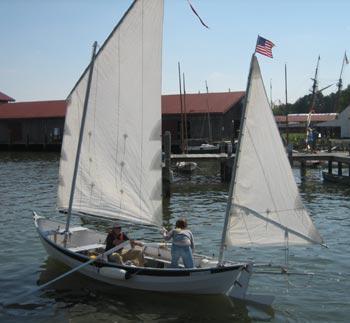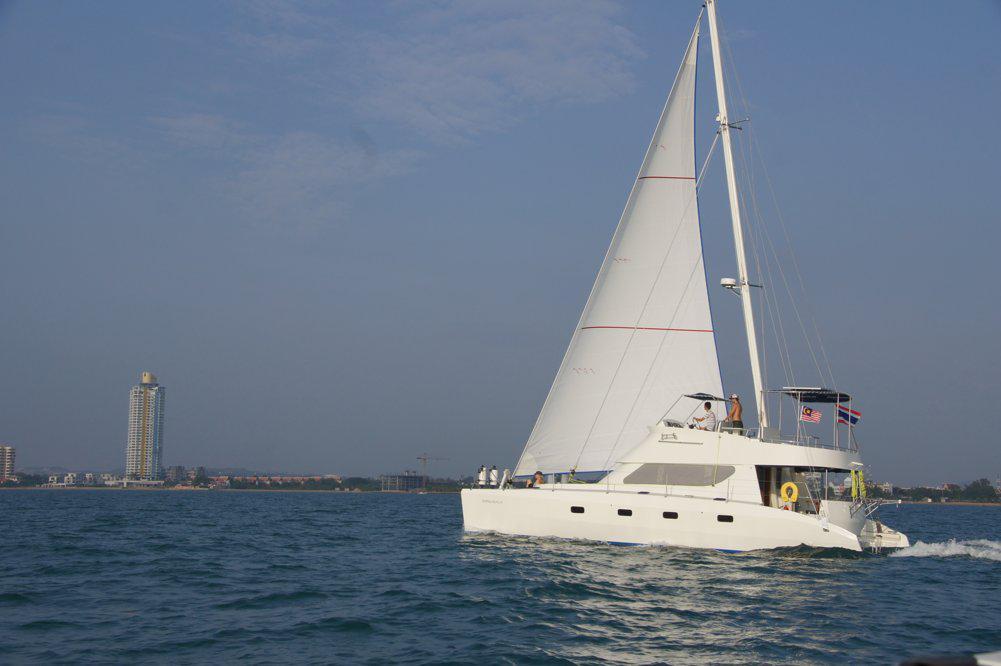The first image is the image on the left, the second image is the image on the right. For the images shown, is this caption "A sailboat with red sails is in the water." true? Answer yes or no. No. 